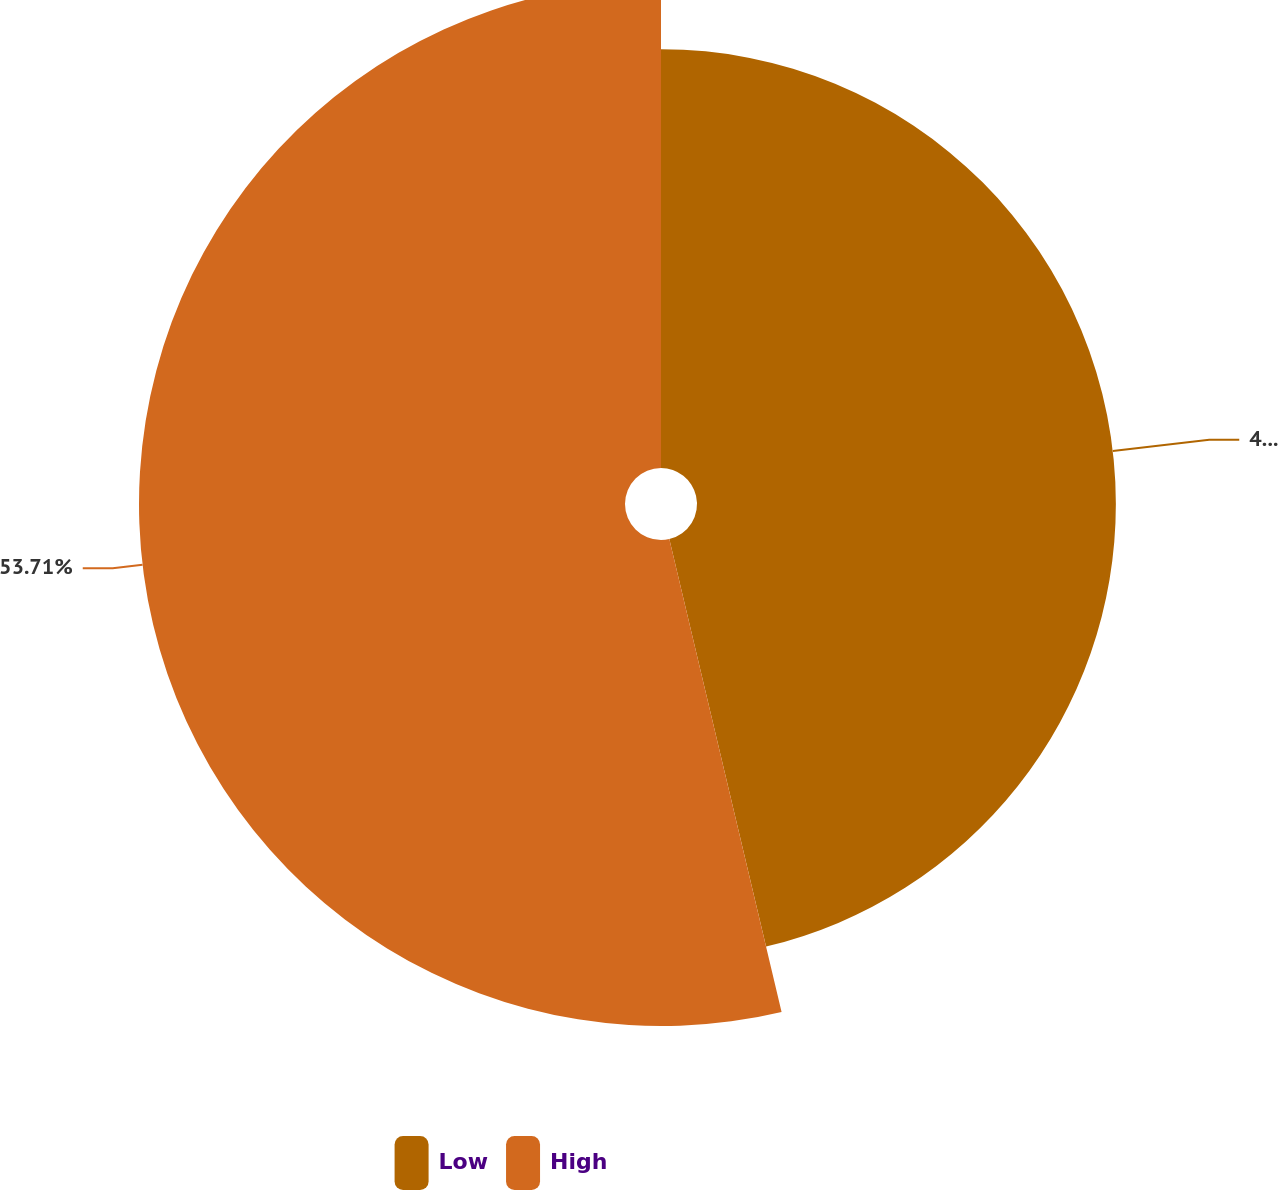Convert chart to OTSL. <chart><loc_0><loc_0><loc_500><loc_500><pie_chart><fcel>Low<fcel>High<nl><fcel>46.29%<fcel>53.71%<nl></chart> 